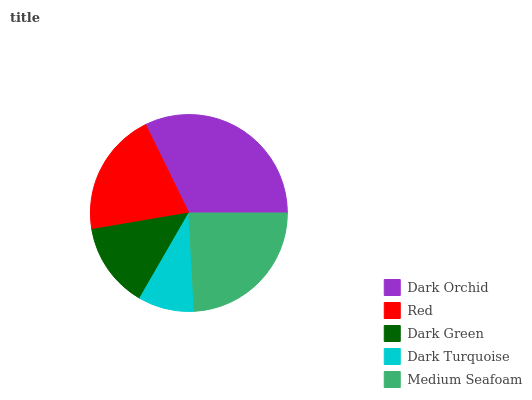Is Dark Turquoise the minimum?
Answer yes or no. Yes. Is Dark Orchid the maximum?
Answer yes or no. Yes. Is Red the minimum?
Answer yes or no. No. Is Red the maximum?
Answer yes or no. No. Is Dark Orchid greater than Red?
Answer yes or no. Yes. Is Red less than Dark Orchid?
Answer yes or no. Yes. Is Red greater than Dark Orchid?
Answer yes or no. No. Is Dark Orchid less than Red?
Answer yes or no. No. Is Red the high median?
Answer yes or no. Yes. Is Red the low median?
Answer yes or no. Yes. Is Dark Green the high median?
Answer yes or no. No. Is Dark Green the low median?
Answer yes or no. No. 